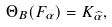<formula> <loc_0><loc_0><loc_500><loc_500>\Theta _ { B } ( F _ { \alpha } ) = K _ { \widehat { \alpha } } ,</formula> 